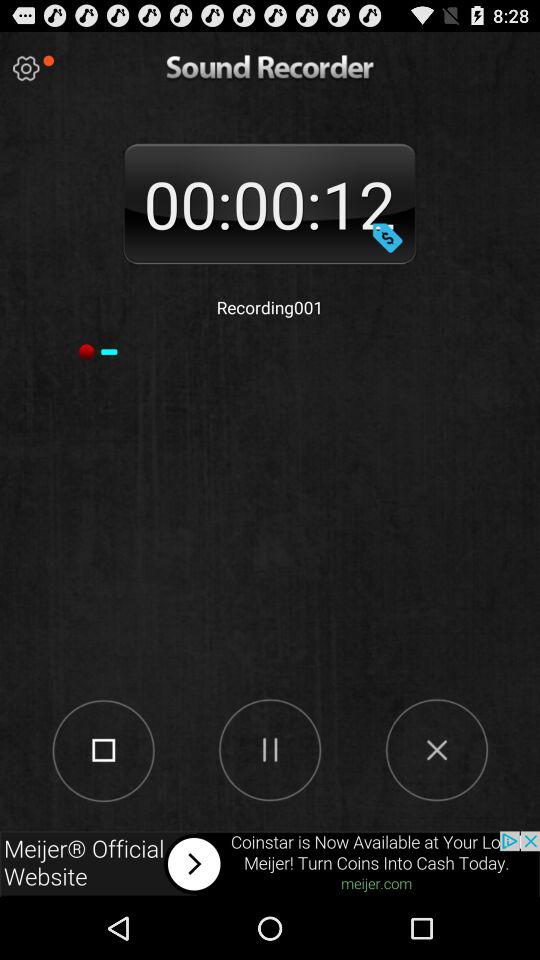What is the duration of "recordings001"? The duration is 12 seconds. 